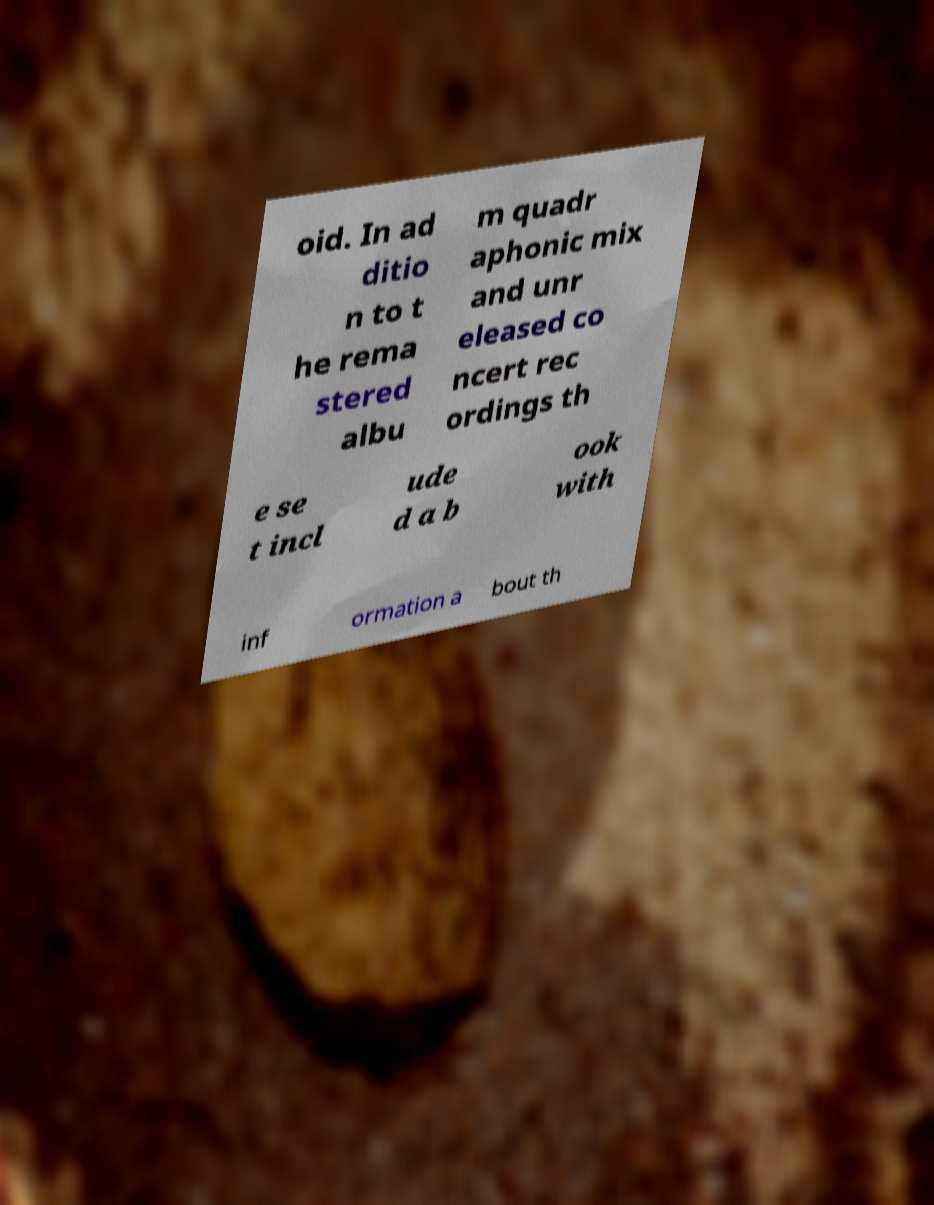Please identify and transcribe the text found in this image. oid. In ad ditio n to t he rema stered albu m quadr aphonic mix and unr eleased co ncert rec ordings th e se t incl ude d a b ook with inf ormation a bout th 